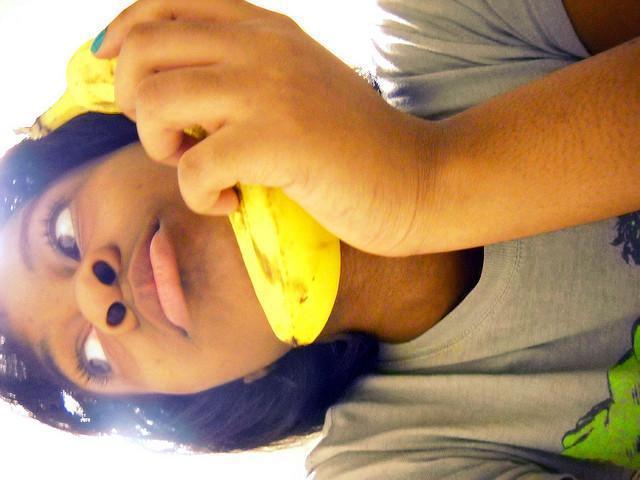How many ski poles are there?
Give a very brief answer. 0. 